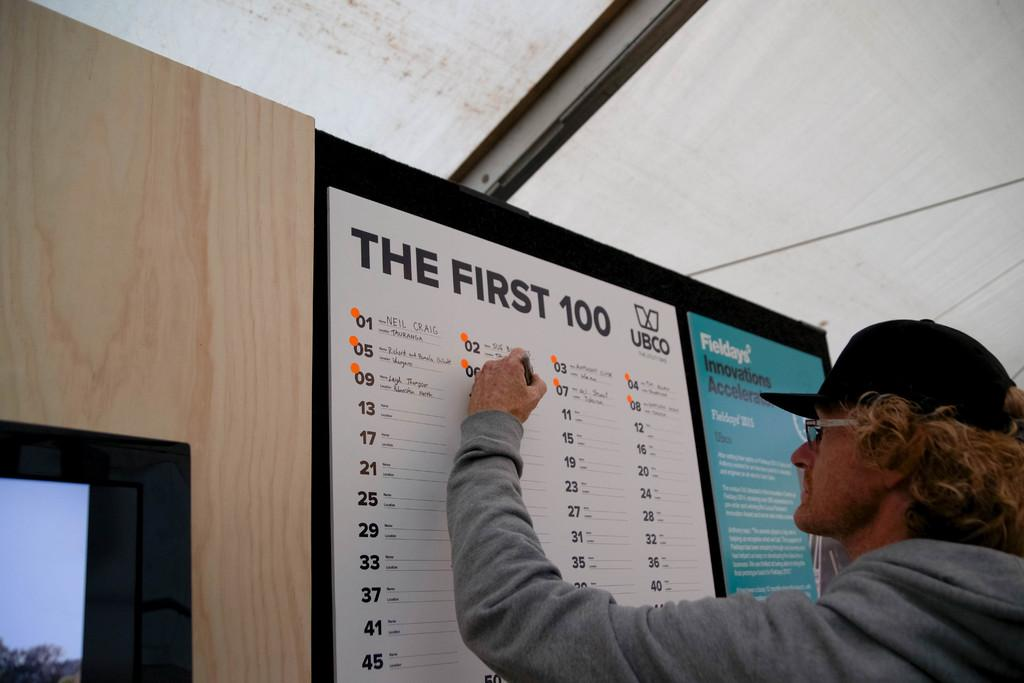<image>
Provide a brief description of the given image. A sign is labeled the first 100 and someone is writing on it. 